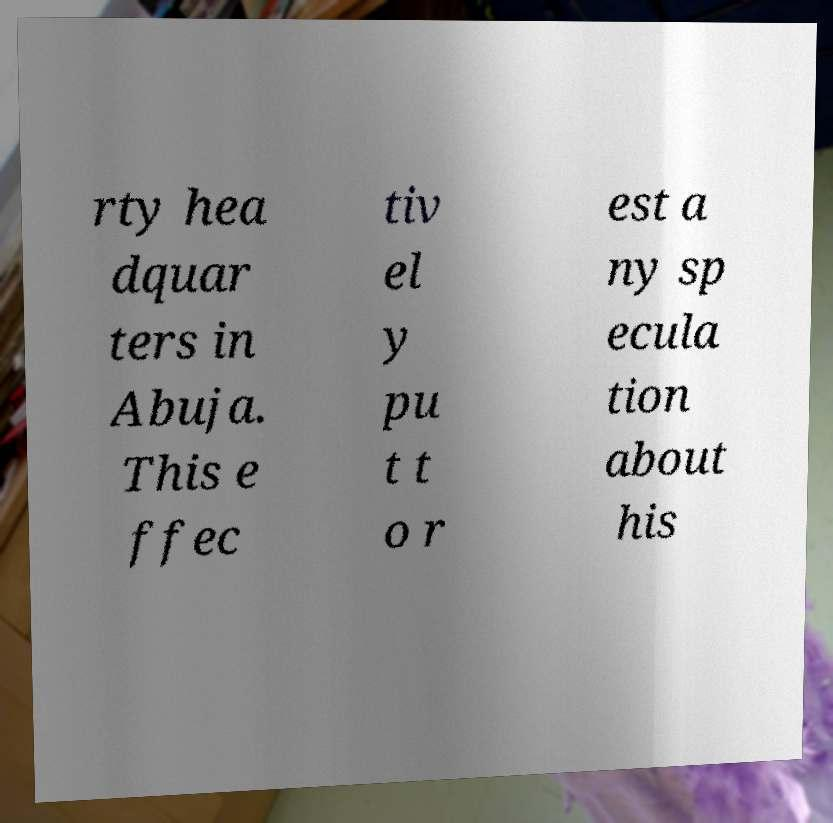Please identify and transcribe the text found in this image. rty hea dquar ters in Abuja. This e ffec tiv el y pu t t o r est a ny sp ecula tion about his 